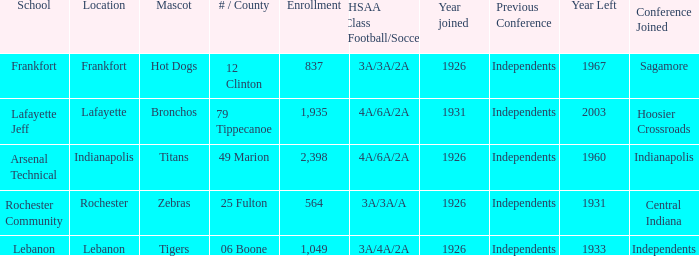What is the lowest enrollment that has Lafayette as the location? 1935.0. 